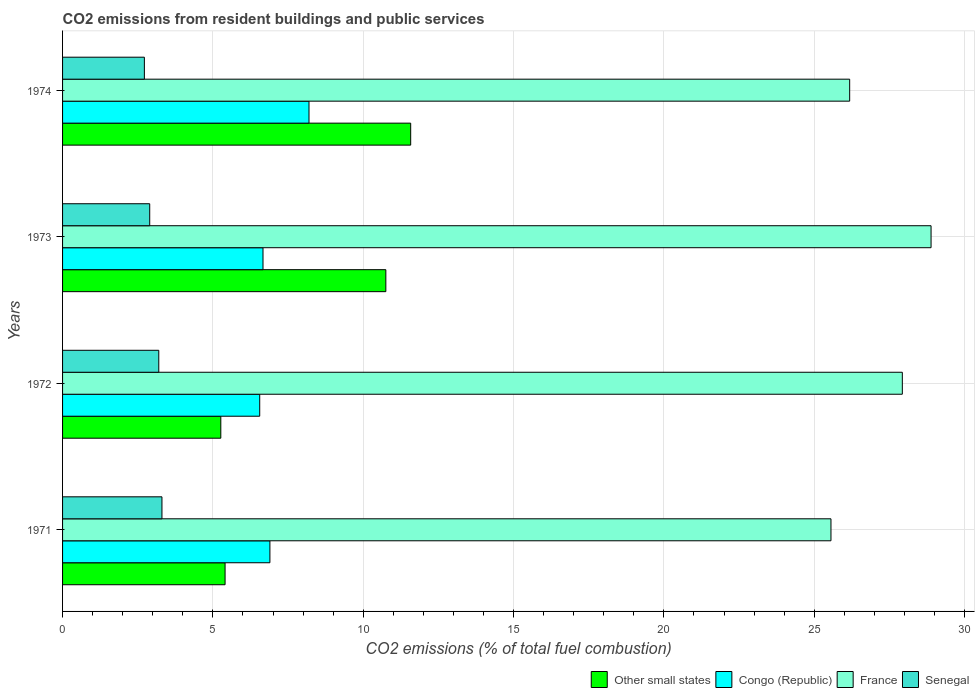How many different coloured bars are there?
Ensure brevity in your answer.  4. How many groups of bars are there?
Your answer should be compact. 4. Are the number of bars per tick equal to the number of legend labels?
Offer a terse response. Yes. Are the number of bars on each tick of the Y-axis equal?
Your answer should be compact. Yes. How many bars are there on the 4th tick from the top?
Give a very brief answer. 4. How many bars are there on the 4th tick from the bottom?
Provide a short and direct response. 4. In how many cases, is the number of bars for a given year not equal to the number of legend labels?
Offer a terse response. 0. What is the total CO2 emitted in France in 1972?
Your response must be concise. 27.93. Across all years, what is the maximum total CO2 emitted in Other small states?
Provide a short and direct response. 11.58. Across all years, what is the minimum total CO2 emitted in Other small states?
Provide a short and direct response. 5.26. In which year was the total CO2 emitted in Senegal maximum?
Ensure brevity in your answer.  1971. What is the total total CO2 emitted in Congo (Republic) in the graph?
Give a very brief answer. 28.32. What is the difference between the total CO2 emitted in France in 1971 and that in 1974?
Offer a terse response. -0.62. What is the difference between the total CO2 emitted in Senegal in 1973 and the total CO2 emitted in Other small states in 1972?
Provide a short and direct response. -2.36. What is the average total CO2 emitted in Senegal per year?
Provide a succinct answer. 3.03. In the year 1971, what is the difference between the total CO2 emitted in France and total CO2 emitted in Senegal?
Make the answer very short. 22.25. What is the ratio of the total CO2 emitted in Senegal in 1971 to that in 1972?
Keep it short and to the point. 1.03. Is the total CO2 emitted in Congo (Republic) in 1971 less than that in 1974?
Provide a succinct answer. Yes. Is the difference between the total CO2 emitted in France in 1972 and 1973 greater than the difference between the total CO2 emitted in Senegal in 1972 and 1973?
Your response must be concise. No. What is the difference between the highest and the second highest total CO2 emitted in France?
Keep it short and to the point. 0.96. What is the difference between the highest and the lowest total CO2 emitted in Other small states?
Make the answer very short. 6.32. Is the sum of the total CO2 emitted in Congo (Republic) in 1971 and 1973 greater than the maximum total CO2 emitted in Other small states across all years?
Provide a succinct answer. Yes. What does the 4th bar from the top in 1974 represents?
Give a very brief answer. Other small states. What does the 2nd bar from the bottom in 1971 represents?
Offer a terse response. Congo (Republic). Is it the case that in every year, the sum of the total CO2 emitted in Congo (Republic) and total CO2 emitted in Other small states is greater than the total CO2 emitted in Senegal?
Offer a very short reply. Yes. How many bars are there?
Provide a short and direct response. 16. How many years are there in the graph?
Your answer should be very brief. 4. What is the difference between two consecutive major ticks on the X-axis?
Provide a short and direct response. 5. Does the graph contain grids?
Provide a succinct answer. Yes. What is the title of the graph?
Offer a terse response. CO2 emissions from resident buildings and public services. What is the label or title of the X-axis?
Your answer should be compact. CO2 emissions (% of total fuel combustion). What is the label or title of the Y-axis?
Your answer should be compact. Years. What is the CO2 emissions (% of total fuel combustion) of Other small states in 1971?
Your answer should be very brief. 5.41. What is the CO2 emissions (% of total fuel combustion) in Congo (Republic) in 1971?
Provide a succinct answer. 6.9. What is the CO2 emissions (% of total fuel combustion) in France in 1971?
Your answer should be compact. 25.56. What is the CO2 emissions (% of total fuel combustion) in Senegal in 1971?
Your response must be concise. 3.31. What is the CO2 emissions (% of total fuel combustion) in Other small states in 1972?
Provide a succinct answer. 5.26. What is the CO2 emissions (% of total fuel combustion) of Congo (Republic) in 1972?
Offer a very short reply. 6.56. What is the CO2 emissions (% of total fuel combustion) of France in 1972?
Your answer should be compact. 27.93. What is the CO2 emissions (% of total fuel combustion) of Senegal in 1972?
Your answer should be very brief. 3.2. What is the CO2 emissions (% of total fuel combustion) in Other small states in 1973?
Your answer should be compact. 10.75. What is the CO2 emissions (% of total fuel combustion) of Congo (Republic) in 1973?
Your answer should be very brief. 6.67. What is the CO2 emissions (% of total fuel combustion) of France in 1973?
Offer a terse response. 28.89. What is the CO2 emissions (% of total fuel combustion) in Senegal in 1973?
Give a very brief answer. 2.9. What is the CO2 emissions (% of total fuel combustion) of Other small states in 1974?
Ensure brevity in your answer.  11.58. What is the CO2 emissions (% of total fuel combustion) in Congo (Republic) in 1974?
Make the answer very short. 8.2. What is the CO2 emissions (% of total fuel combustion) in France in 1974?
Your response must be concise. 26.18. What is the CO2 emissions (% of total fuel combustion) in Senegal in 1974?
Provide a short and direct response. 2.72. Across all years, what is the maximum CO2 emissions (% of total fuel combustion) in Other small states?
Keep it short and to the point. 11.58. Across all years, what is the maximum CO2 emissions (% of total fuel combustion) of Congo (Republic)?
Provide a succinct answer. 8.2. Across all years, what is the maximum CO2 emissions (% of total fuel combustion) in France?
Ensure brevity in your answer.  28.89. Across all years, what is the maximum CO2 emissions (% of total fuel combustion) of Senegal?
Ensure brevity in your answer.  3.31. Across all years, what is the minimum CO2 emissions (% of total fuel combustion) in Other small states?
Provide a succinct answer. 5.26. Across all years, what is the minimum CO2 emissions (% of total fuel combustion) of Congo (Republic)?
Your answer should be compact. 6.56. Across all years, what is the minimum CO2 emissions (% of total fuel combustion) of France?
Make the answer very short. 25.56. Across all years, what is the minimum CO2 emissions (% of total fuel combustion) in Senegal?
Ensure brevity in your answer.  2.72. What is the total CO2 emissions (% of total fuel combustion) of Other small states in the graph?
Make the answer very short. 33. What is the total CO2 emissions (% of total fuel combustion) of Congo (Republic) in the graph?
Your answer should be compact. 28.32. What is the total CO2 emissions (% of total fuel combustion) of France in the graph?
Offer a very short reply. 108.56. What is the total CO2 emissions (% of total fuel combustion) in Senegal in the graph?
Provide a short and direct response. 12.13. What is the difference between the CO2 emissions (% of total fuel combustion) of Other small states in 1971 and that in 1972?
Give a very brief answer. 0.14. What is the difference between the CO2 emissions (% of total fuel combustion) of Congo (Republic) in 1971 and that in 1972?
Provide a succinct answer. 0.34. What is the difference between the CO2 emissions (% of total fuel combustion) in France in 1971 and that in 1972?
Offer a very short reply. -2.37. What is the difference between the CO2 emissions (% of total fuel combustion) of Senegal in 1971 and that in 1972?
Give a very brief answer. 0.11. What is the difference between the CO2 emissions (% of total fuel combustion) in Other small states in 1971 and that in 1973?
Provide a short and direct response. -5.35. What is the difference between the CO2 emissions (% of total fuel combustion) in Congo (Republic) in 1971 and that in 1973?
Provide a short and direct response. 0.23. What is the difference between the CO2 emissions (% of total fuel combustion) of France in 1971 and that in 1973?
Keep it short and to the point. -3.33. What is the difference between the CO2 emissions (% of total fuel combustion) in Senegal in 1971 and that in 1973?
Your answer should be very brief. 0.41. What is the difference between the CO2 emissions (% of total fuel combustion) in Other small states in 1971 and that in 1974?
Offer a very short reply. -6.17. What is the difference between the CO2 emissions (% of total fuel combustion) in Congo (Republic) in 1971 and that in 1974?
Your answer should be very brief. -1.3. What is the difference between the CO2 emissions (% of total fuel combustion) in France in 1971 and that in 1974?
Your answer should be very brief. -0.62. What is the difference between the CO2 emissions (% of total fuel combustion) of Senegal in 1971 and that in 1974?
Your response must be concise. 0.58. What is the difference between the CO2 emissions (% of total fuel combustion) in Other small states in 1972 and that in 1973?
Provide a succinct answer. -5.49. What is the difference between the CO2 emissions (% of total fuel combustion) of Congo (Republic) in 1972 and that in 1973?
Make the answer very short. -0.11. What is the difference between the CO2 emissions (% of total fuel combustion) in France in 1972 and that in 1973?
Give a very brief answer. -0.96. What is the difference between the CO2 emissions (% of total fuel combustion) of Senegal in 1972 and that in 1973?
Provide a succinct answer. 0.3. What is the difference between the CO2 emissions (% of total fuel combustion) in Other small states in 1972 and that in 1974?
Provide a short and direct response. -6.32. What is the difference between the CO2 emissions (% of total fuel combustion) in Congo (Republic) in 1972 and that in 1974?
Your response must be concise. -1.64. What is the difference between the CO2 emissions (% of total fuel combustion) in France in 1972 and that in 1974?
Provide a succinct answer. 1.75. What is the difference between the CO2 emissions (% of total fuel combustion) in Senegal in 1972 and that in 1974?
Provide a succinct answer. 0.48. What is the difference between the CO2 emissions (% of total fuel combustion) in Other small states in 1973 and that in 1974?
Your answer should be very brief. -0.83. What is the difference between the CO2 emissions (% of total fuel combustion) of Congo (Republic) in 1973 and that in 1974?
Your answer should be compact. -1.53. What is the difference between the CO2 emissions (% of total fuel combustion) in France in 1973 and that in 1974?
Keep it short and to the point. 2.71. What is the difference between the CO2 emissions (% of total fuel combustion) of Senegal in 1973 and that in 1974?
Your answer should be very brief. 0.18. What is the difference between the CO2 emissions (% of total fuel combustion) of Other small states in 1971 and the CO2 emissions (% of total fuel combustion) of Congo (Republic) in 1972?
Offer a terse response. -1.15. What is the difference between the CO2 emissions (% of total fuel combustion) of Other small states in 1971 and the CO2 emissions (% of total fuel combustion) of France in 1972?
Offer a very short reply. -22.53. What is the difference between the CO2 emissions (% of total fuel combustion) in Other small states in 1971 and the CO2 emissions (% of total fuel combustion) in Senegal in 1972?
Offer a very short reply. 2.21. What is the difference between the CO2 emissions (% of total fuel combustion) of Congo (Republic) in 1971 and the CO2 emissions (% of total fuel combustion) of France in 1972?
Offer a terse response. -21.03. What is the difference between the CO2 emissions (% of total fuel combustion) of Congo (Republic) in 1971 and the CO2 emissions (% of total fuel combustion) of Senegal in 1972?
Your answer should be compact. 3.7. What is the difference between the CO2 emissions (% of total fuel combustion) of France in 1971 and the CO2 emissions (% of total fuel combustion) of Senegal in 1972?
Keep it short and to the point. 22.36. What is the difference between the CO2 emissions (% of total fuel combustion) of Other small states in 1971 and the CO2 emissions (% of total fuel combustion) of Congo (Republic) in 1973?
Your answer should be very brief. -1.26. What is the difference between the CO2 emissions (% of total fuel combustion) in Other small states in 1971 and the CO2 emissions (% of total fuel combustion) in France in 1973?
Your answer should be compact. -23.48. What is the difference between the CO2 emissions (% of total fuel combustion) of Other small states in 1971 and the CO2 emissions (% of total fuel combustion) of Senegal in 1973?
Keep it short and to the point. 2.51. What is the difference between the CO2 emissions (% of total fuel combustion) of Congo (Republic) in 1971 and the CO2 emissions (% of total fuel combustion) of France in 1973?
Provide a succinct answer. -21.99. What is the difference between the CO2 emissions (% of total fuel combustion) of Congo (Republic) in 1971 and the CO2 emissions (% of total fuel combustion) of Senegal in 1973?
Give a very brief answer. 4. What is the difference between the CO2 emissions (% of total fuel combustion) in France in 1971 and the CO2 emissions (% of total fuel combustion) in Senegal in 1973?
Make the answer very short. 22.66. What is the difference between the CO2 emissions (% of total fuel combustion) in Other small states in 1971 and the CO2 emissions (% of total fuel combustion) in Congo (Republic) in 1974?
Your response must be concise. -2.79. What is the difference between the CO2 emissions (% of total fuel combustion) of Other small states in 1971 and the CO2 emissions (% of total fuel combustion) of France in 1974?
Your response must be concise. -20.77. What is the difference between the CO2 emissions (% of total fuel combustion) of Other small states in 1971 and the CO2 emissions (% of total fuel combustion) of Senegal in 1974?
Provide a succinct answer. 2.68. What is the difference between the CO2 emissions (% of total fuel combustion) of Congo (Republic) in 1971 and the CO2 emissions (% of total fuel combustion) of France in 1974?
Your answer should be compact. -19.28. What is the difference between the CO2 emissions (% of total fuel combustion) of Congo (Republic) in 1971 and the CO2 emissions (% of total fuel combustion) of Senegal in 1974?
Offer a very short reply. 4.18. What is the difference between the CO2 emissions (% of total fuel combustion) in France in 1971 and the CO2 emissions (% of total fuel combustion) in Senegal in 1974?
Offer a very short reply. 22.84. What is the difference between the CO2 emissions (% of total fuel combustion) in Other small states in 1972 and the CO2 emissions (% of total fuel combustion) in Congo (Republic) in 1973?
Offer a very short reply. -1.4. What is the difference between the CO2 emissions (% of total fuel combustion) of Other small states in 1972 and the CO2 emissions (% of total fuel combustion) of France in 1973?
Keep it short and to the point. -23.62. What is the difference between the CO2 emissions (% of total fuel combustion) in Other small states in 1972 and the CO2 emissions (% of total fuel combustion) in Senegal in 1973?
Ensure brevity in your answer.  2.36. What is the difference between the CO2 emissions (% of total fuel combustion) of Congo (Republic) in 1972 and the CO2 emissions (% of total fuel combustion) of France in 1973?
Make the answer very short. -22.33. What is the difference between the CO2 emissions (% of total fuel combustion) in Congo (Republic) in 1972 and the CO2 emissions (% of total fuel combustion) in Senegal in 1973?
Ensure brevity in your answer.  3.66. What is the difference between the CO2 emissions (% of total fuel combustion) of France in 1972 and the CO2 emissions (% of total fuel combustion) of Senegal in 1973?
Keep it short and to the point. 25.03. What is the difference between the CO2 emissions (% of total fuel combustion) in Other small states in 1972 and the CO2 emissions (% of total fuel combustion) in Congo (Republic) in 1974?
Make the answer very short. -2.93. What is the difference between the CO2 emissions (% of total fuel combustion) in Other small states in 1972 and the CO2 emissions (% of total fuel combustion) in France in 1974?
Offer a terse response. -20.92. What is the difference between the CO2 emissions (% of total fuel combustion) in Other small states in 1972 and the CO2 emissions (% of total fuel combustion) in Senegal in 1974?
Ensure brevity in your answer.  2.54. What is the difference between the CO2 emissions (% of total fuel combustion) in Congo (Republic) in 1972 and the CO2 emissions (% of total fuel combustion) in France in 1974?
Offer a very short reply. -19.62. What is the difference between the CO2 emissions (% of total fuel combustion) of Congo (Republic) in 1972 and the CO2 emissions (% of total fuel combustion) of Senegal in 1974?
Your response must be concise. 3.84. What is the difference between the CO2 emissions (% of total fuel combustion) of France in 1972 and the CO2 emissions (% of total fuel combustion) of Senegal in 1974?
Provide a succinct answer. 25.21. What is the difference between the CO2 emissions (% of total fuel combustion) of Other small states in 1973 and the CO2 emissions (% of total fuel combustion) of Congo (Republic) in 1974?
Your response must be concise. 2.56. What is the difference between the CO2 emissions (% of total fuel combustion) in Other small states in 1973 and the CO2 emissions (% of total fuel combustion) in France in 1974?
Offer a terse response. -15.43. What is the difference between the CO2 emissions (% of total fuel combustion) of Other small states in 1973 and the CO2 emissions (% of total fuel combustion) of Senegal in 1974?
Keep it short and to the point. 8.03. What is the difference between the CO2 emissions (% of total fuel combustion) in Congo (Republic) in 1973 and the CO2 emissions (% of total fuel combustion) in France in 1974?
Provide a succinct answer. -19.51. What is the difference between the CO2 emissions (% of total fuel combustion) in Congo (Republic) in 1973 and the CO2 emissions (% of total fuel combustion) in Senegal in 1974?
Provide a succinct answer. 3.95. What is the difference between the CO2 emissions (% of total fuel combustion) in France in 1973 and the CO2 emissions (% of total fuel combustion) in Senegal in 1974?
Give a very brief answer. 26.17. What is the average CO2 emissions (% of total fuel combustion) in Other small states per year?
Your response must be concise. 8.25. What is the average CO2 emissions (% of total fuel combustion) of Congo (Republic) per year?
Your response must be concise. 7.08. What is the average CO2 emissions (% of total fuel combustion) in France per year?
Give a very brief answer. 27.14. What is the average CO2 emissions (% of total fuel combustion) in Senegal per year?
Give a very brief answer. 3.03. In the year 1971, what is the difference between the CO2 emissions (% of total fuel combustion) of Other small states and CO2 emissions (% of total fuel combustion) of Congo (Republic)?
Make the answer very short. -1.49. In the year 1971, what is the difference between the CO2 emissions (% of total fuel combustion) of Other small states and CO2 emissions (% of total fuel combustion) of France?
Ensure brevity in your answer.  -20.15. In the year 1971, what is the difference between the CO2 emissions (% of total fuel combustion) of Other small states and CO2 emissions (% of total fuel combustion) of Senegal?
Give a very brief answer. 2.1. In the year 1971, what is the difference between the CO2 emissions (% of total fuel combustion) in Congo (Republic) and CO2 emissions (% of total fuel combustion) in France?
Provide a short and direct response. -18.66. In the year 1971, what is the difference between the CO2 emissions (% of total fuel combustion) of Congo (Republic) and CO2 emissions (% of total fuel combustion) of Senegal?
Provide a succinct answer. 3.59. In the year 1971, what is the difference between the CO2 emissions (% of total fuel combustion) in France and CO2 emissions (% of total fuel combustion) in Senegal?
Keep it short and to the point. 22.25. In the year 1972, what is the difference between the CO2 emissions (% of total fuel combustion) of Other small states and CO2 emissions (% of total fuel combustion) of Congo (Republic)?
Make the answer very short. -1.29. In the year 1972, what is the difference between the CO2 emissions (% of total fuel combustion) in Other small states and CO2 emissions (% of total fuel combustion) in France?
Your response must be concise. -22.67. In the year 1972, what is the difference between the CO2 emissions (% of total fuel combustion) of Other small states and CO2 emissions (% of total fuel combustion) of Senegal?
Offer a very short reply. 2.06. In the year 1972, what is the difference between the CO2 emissions (% of total fuel combustion) of Congo (Republic) and CO2 emissions (% of total fuel combustion) of France?
Offer a terse response. -21.37. In the year 1972, what is the difference between the CO2 emissions (% of total fuel combustion) of Congo (Republic) and CO2 emissions (% of total fuel combustion) of Senegal?
Your answer should be very brief. 3.36. In the year 1972, what is the difference between the CO2 emissions (% of total fuel combustion) in France and CO2 emissions (% of total fuel combustion) in Senegal?
Provide a succinct answer. 24.73. In the year 1973, what is the difference between the CO2 emissions (% of total fuel combustion) in Other small states and CO2 emissions (% of total fuel combustion) in Congo (Republic)?
Offer a terse response. 4.09. In the year 1973, what is the difference between the CO2 emissions (% of total fuel combustion) of Other small states and CO2 emissions (% of total fuel combustion) of France?
Offer a very short reply. -18.13. In the year 1973, what is the difference between the CO2 emissions (% of total fuel combustion) of Other small states and CO2 emissions (% of total fuel combustion) of Senegal?
Offer a very short reply. 7.85. In the year 1973, what is the difference between the CO2 emissions (% of total fuel combustion) of Congo (Republic) and CO2 emissions (% of total fuel combustion) of France?
Your answer should be very brief. -22.22. In the year 1973, what is the difference between the CO2 emissions (% of total fuel combustion) in Congo (Republic) and CO2 emissions (% of total fuel combustion) in Senegal?
Offer a terse response. 3.77. In the year 1973, what is the difference between the CO2 emissions (% of total fuel combustion) of France and CO2 emissions (% of total fuel combustion) of Senegal?
Your response must be concise. 25.99. In the year 1974, what is the difference between the CO2 emissions (% of total fuel combustion) in Other small states and CO2 emissions (% of total fuel combustion) in Congo (Republic)?
Your answer should be compact. 3.38. In the year 1974, what is the difference between the CO2 emissions (% of total fuel combustion) in Other small states and CO2 emissions (% of total fuel combustion) in France?
Make the answer very short. -14.6. In the year 1974, what is the difference between the CO2 emissions (% of total fuel combustion) in Other small states and CO2 emissions (% of total fuel combustion) in Senegal?
Give a very brief answer. 8.86. In the year 1974, what is the difference between the CO2 emissions (% of total fuel combustion) in Congo (Republic) and CO2 emissions (% of total fuel combustion) in France?
Your answer should be compact. -17.98. In the year 1974, what is the difference between the CO2 emissions (% of total fuel combustion) in Congo (Republic) and CO2 emissions (% of total fuel combustion) in Senegal?
Offer a very short reply. 5.48. In the year 1974, what is the difference between the CO2 emissions (% of total fuel combustion) of France and CO2 emissions (% of total fuel combustion) of Senegal?
Keep it short and to the point. 23.46. What is the ratio of the CO2 emissions (% of total fuel combustion) in Other small states in 1971 to that in 1972?
Make the answer very short. 1.03. What is the ratio of the CO2 emissions (% of total fuel combustion) in Congo (Republic) in 1971 to that in 1972?
Provide a short and direct response. 1.05. What is the ratio of the CO2 emissions (% of total fuel combustion) in France in 1971 to that in 1972?
Your response must be concise. 0.92. What is the ratio of the CO2 emissions (% of total fuel combustion) of Senegal in 1971 to that in 1972?
Offer a terse response. 1.03. What is the ratio of the CO2 emissions (% of total fuel combustion) of Other small states in 1971 to that in 1973?
Provide a short and direct response. 0.5. What is the ratio of the CO2 emissions (% of total fuel combustion) in Congo (Republic) in 1971 to that in 1973?
Your response must be concise. 1.03. What is the ratio of the CO2 emissions (% of total fuel combustion) of France in 1971 to that in 1973?
Keep it short and to the point. 0.88. What is the ratio of the CO2 emissions (% of total fuel combustion) of Senegal in 1971 to that in 1973?
Keep it short and to the point. 1.14. What is the ratio of the CO2 emissions (% of total fuel combustion) in Other small states in 1971 to that in 1974?
Your response must be concise. 0.47. What is the ratio of the CO2 emissions (% of total fuel combustion) in Congo (Republic) in 1971 to that in 1974?
Offer a very short reply. 0.84. What is the ratio of the CO2 emissions (% of total fuel combustion) in France in 1971 to that in 1974?
Provide a succinct answer. 0.98. What is the ratio of the CO2 emissions (% of total fuel combustion) in Senegal in 1971 to that in 1974?
Offer a terse response. 1.21. What is the ratio of the CO2 emissions (% of total fuel combustion) of Other small states in 1972 to that in 1973?
Provide a succinct answer. 0.49. What is the ratio of the CO2 emissions (% of total fuel combustion) of Congo (Republic) in 1972 to that in 1973?
Provide a succinct answer. 0.98. What is the ratio of the CO2 emissions (% of total fuel combustion) in France in 1972 to that in 1973?
Your response must be concise. 0.97. What is the ratio of the CO2 emissions (% of total fuel combustion) in Senegal in 1972 to that in 1973?
Offer a terse response. 1.1. What is the ratio of the CO2 emissions (% of total fuel combustion) in Other small states in 1972 to that in 1974?
Offer a very short reply. 0.45. What is the ratio of the CO2 emissions (% of total fuel combustion) of France in 1972 to that in 1974?
Your answer should be compact. 1.07. What is the ratio of the CO2 emissions (% of total fuel combustion) of Senegal in 1972 to that in 1974?
Make the answer very short. 1.18. What is the ratio of the CO2 emissions (% of total fuel combustion) of Congo (Republic) in 1973 to that in 1974?
Offer a very short reply. 0.81. What is the ratio of the CO2 emissions (% of total fuel combustion) in France in 1973 to that in 1974?
Provide a short and direct response. 1.1. What is the ratio of the CO2 emissions (% of total fuel combustion) in Senegal in 1973 to that in 1974?
Offer a terse response. 1.07. What is the difference between the highest and the second highest CO2 emissions (% of total fuel combustion) of Other small states?
Your answer should be compact. 0.83. What is the difference between the highest and the second highest CO2 emissions (% of total fuel combustion) in Congo (Republic)?
Offer a terse response. 1.3. What is the difference between the highest and the second highest CO2 emissions (% of total fuel combustion) in France?
Offer a very short reply. 0.96. What is the difference between the highest and the second highest CO2 emissions (% of total fuel combustion) of Senegal?
Your answer should be very brief. 0.11. What is the difference between the highest and the lowest CO2 emissions (% of total fuel combustion) of Other small states?
Provide a short and direct response. 6.32. What is the difference between the highest and the lowest CO2 emissions (% of total fuel combustion) in Congo (Republic)?
Give a very brief answer. 1.64. What is the difference between the highest and the lowest CO2 emissions (% of total fuel combustion) in France?
Make the answer very short. 3.33. What is the difference between the highest and the lowest CO2 emissions (% of total fuel combustion) of Senegal?
Make the answer very short. 0.58. 